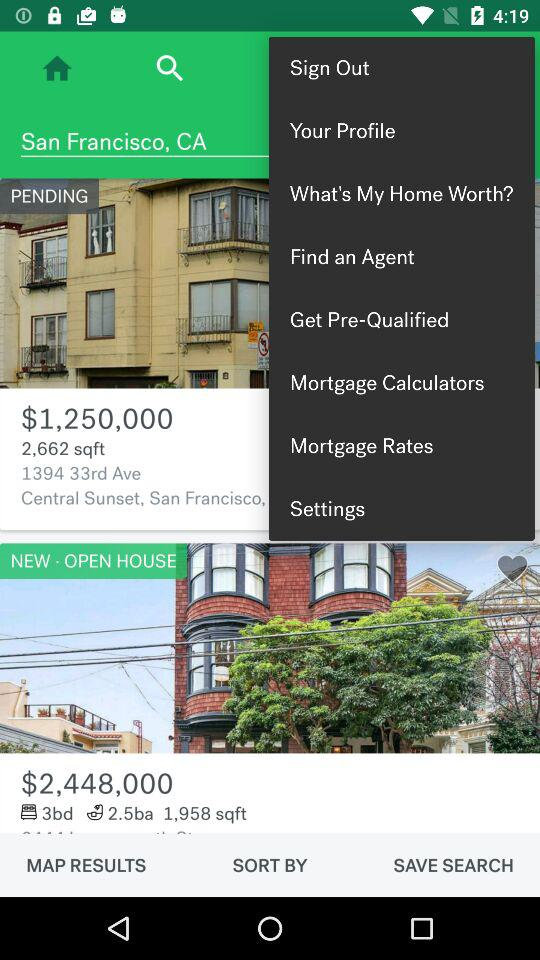What is the area of the new open house? The area is 1,958 square feet. 